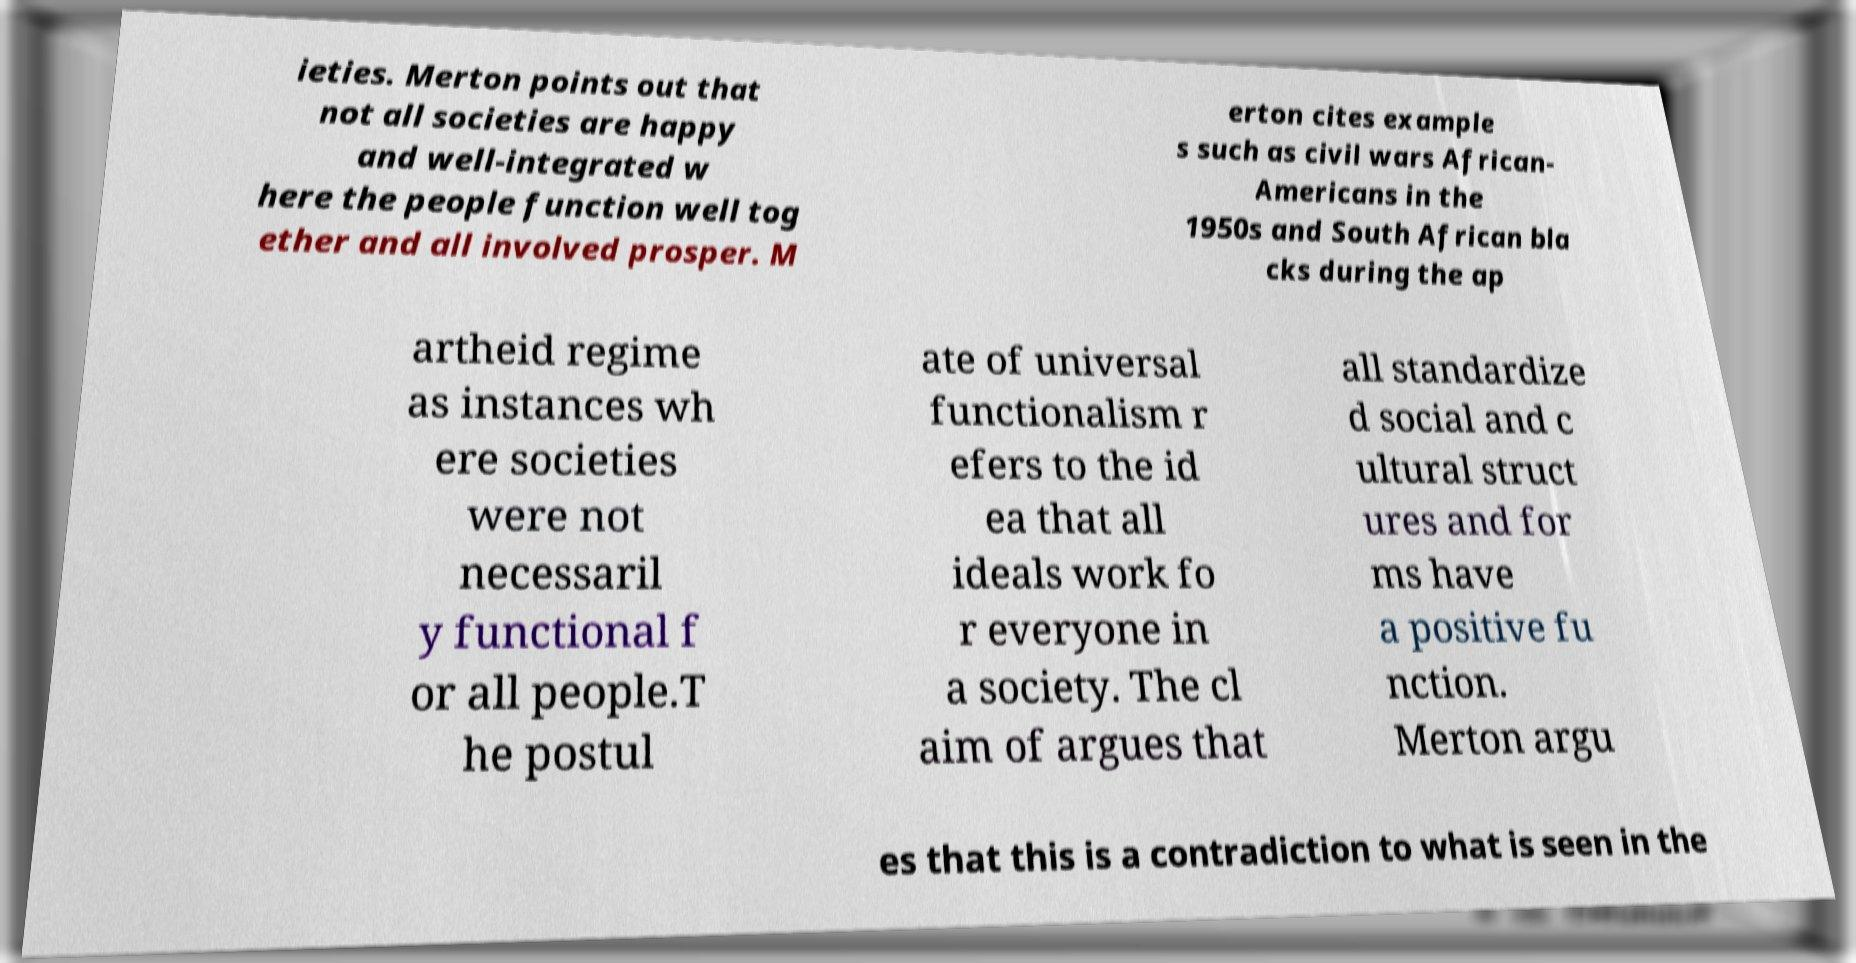Please identify and transcribe the text found in this image. ieties. Merton points out that not all societies are happy and well-integrated w here the people function well tog ether and all involved prosper. M erton cites example s such as civil wars African- Americans in the 1950s and South African bla cks during the ap artheid regime as instances wh ere societies were not necessaril y functional f or all people.T he postul ate of universal functionalism r efers to the id ea that all ideals work fo r everyone in a society. The cl aim of argues that all standardize d social and c ultural struct ures and for ms have a positive fu nction. Merton argu es that this is a contradiction to what is seen in the 